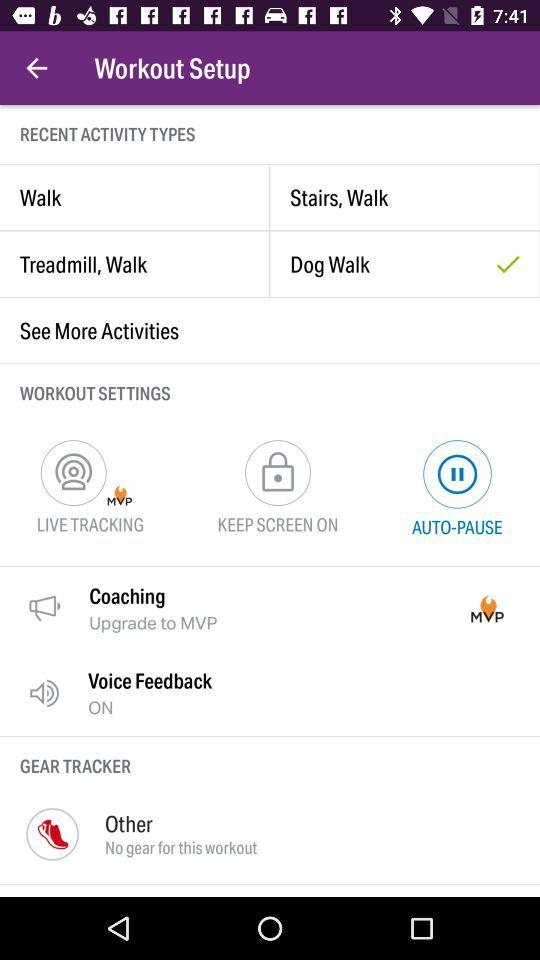What's the status of "Voice Feedback"? The status is "on". 